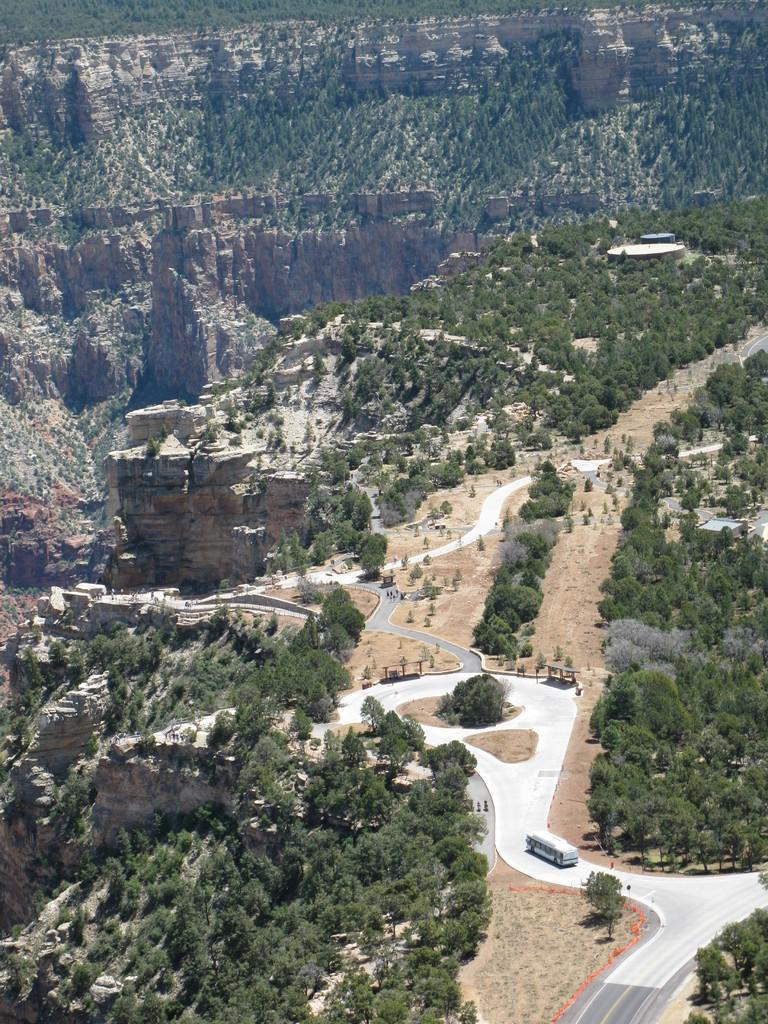What is on the road in the image? There is a vehicle on the road in the image. What type of natural features can be seen in the image? There are trees on the land and hills visible in the background. What structure is located on the right side of the image? There is a building on the right side of the image. Where is the chair placed in the image? There is no chair present in the image. What type of war is depicted in the image? There is no war depicted in the image; it features a vehicle on the road, trees, hills, and a building. 